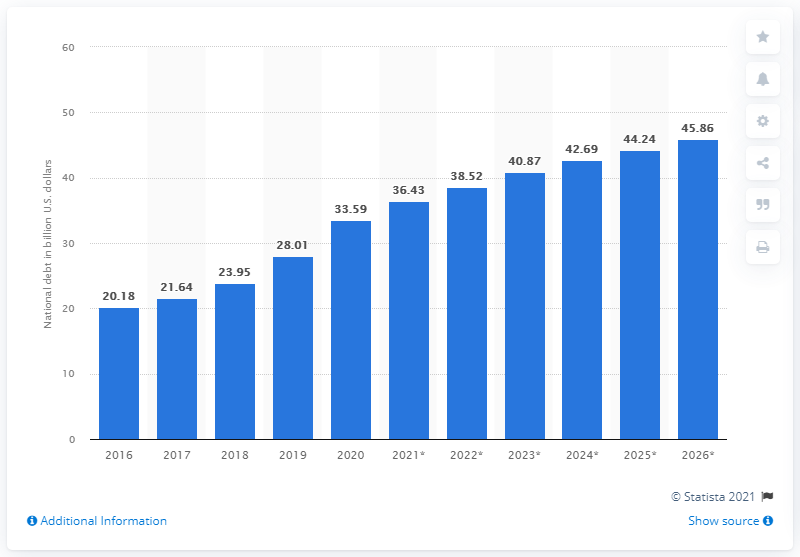Specify some key components in this picture. The national debt of Panama in 2020 was 33.59 billion dollars. In the year 2020, the national debt of Panama was brought to an end. 